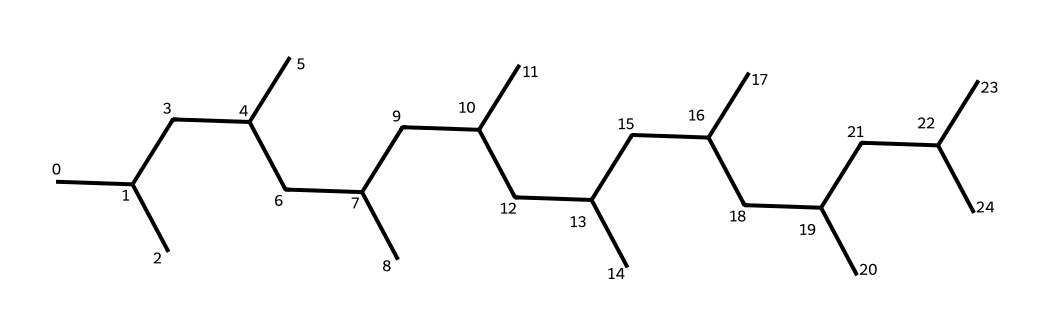What is the degree of saturation of this chemical? This structure represents a fully saturated hydrocarbon, as it contains only single bonds between carbon atoms and no double or triple bonds. Therefore, the degree of saturation is maximum, indicating that all carbon atoms are saturated with hydrogen.
Answer: fully saturated How many carbon atoms are present in this structure? By analyzing the SMILES representation, we can see there are multiple carbon atoms connected in a branched chain. Counting these leads us to find that there are 24 carbon atoms in total.
Answer: 24 What type of lubricants does this chemical represent? Given the branched structure and the fact that it is saturated, this compound can be classified as a paraffin or a saturated hydrocarbon, commonly found in synthetic oils, which are used as lubricants in hydraulic systems.
Answer: synthetic oil What is the functional group present in this chemical? Since this chemical is a branched hydrocarbon with no functional groups shown in the structure or specified in the SMILES, it contains no functional groups such as hydroxyl or carboxyl. It is purely a hydrocarbon.
Answer: none What is the molecular formula corresponding to the SMILES representation? To derive the molecular formula, we count the number of carbons (C) and hydrogens (H). With 24 carbon atoms and following the general formula for alkanes (C_nH_(2n+2)), the formula is C24H50.
Answer: C24H50 